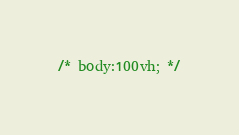<code> <loc_0><loc_0><loc_500><loc_500><_CSS_>/* body:100vh; */

</code> 